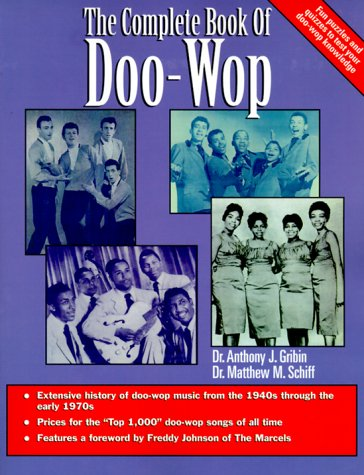Is this a journey related book? While not about physical travels, this book might metaphorically be seen as a journey through the rich history of Doo-Wop and R&B music stretching from the 1940s to the 1970s. 